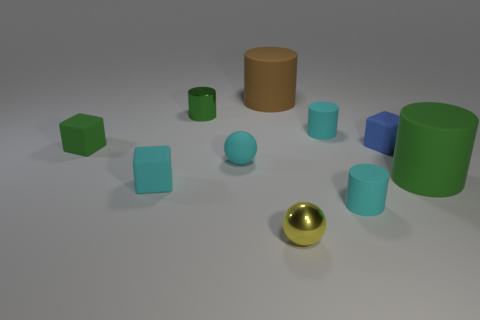Subtract all tiny metallic cylinders. How many cylinders are left? 4 Subtract all brown cylinders. How many cylinders are left? 4 Subtract all gray cylinders. Subtract all red blocks. How many cylinders are left? 5 Subtract all blocks. How many objects are left? 7 Subtract 0 red cylinders. How many objects are left? 10 Subtract all small green cylinders. Subtract all brown rubber cylinders. How many objects are left? 8 Add 1 large cylinders. How many large cylinders are left? 3 Add 1 big blue metallic objects. How many big blue metallic objects exist? 1 